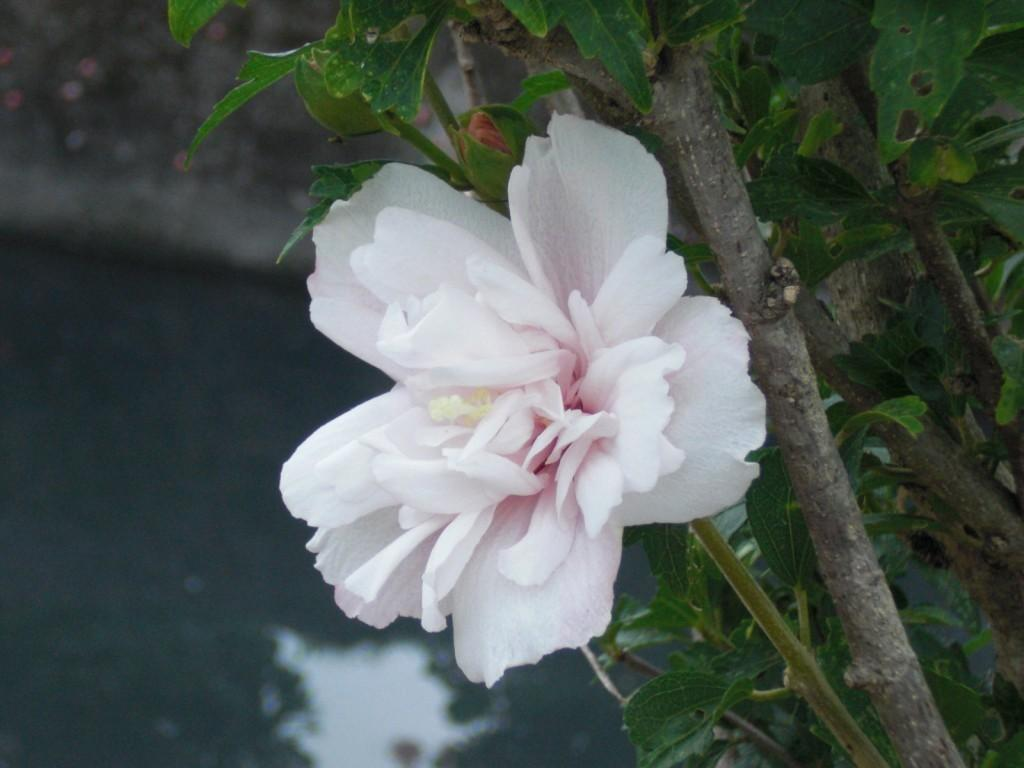What type of flower is present in the image? There is a pink and white color flower in the image. What else can be seen in the image besides the flower? There are leaves visible in the image. What can be seen in the background of the image? Water is visible in the background of the image. Reasoning: Let's think step by step by following the guidelines step by step to produce the conversation. We start by identifying the main subject of the image, which is the flower. Then, we expand the conversation to include other elements present in the image, such as the leaves and the water in the background. Each question is designed to elicit a specific detail about the image that is known from the provided facts. Absurd Question/Answer: What type of oil can be seen dripping from the flower in the image? There is no oil present in the image; it is a flower with leaves and water in the background. 